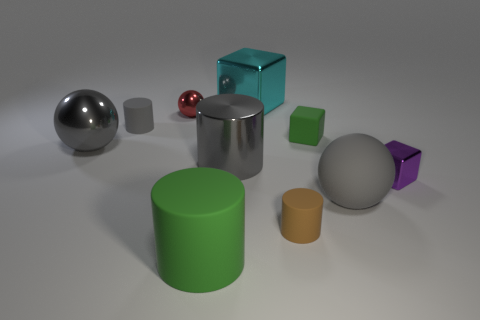Is the large matte sphere the same color as the large shiny cylinder?
Offer a very short reply. Yes. Is there a large gray metal cylinder?
Keep it short and to the point. Yes. What is the size of the metallic ball in front of the small rubber cylinder that is on the left side of the big matte cylinder in front of the large cyan metallic cube?
Ensure brevity in your answer.  Large. How many other things are the same size as the green cylinder?
Offer a terse response. 4. There is a green thing left of the large metallic cube; what size is it?
Ensure brevity in your answer.  Large. Is there any other thing that has the same color as the big rubber sphere?
Provide a succinct answer. Yes. Do the gray cylinder to the right of the small red ball and the small green cube have the same material?
Provide a succinct answer. No. How many matte objects are both in front of the large rubber ball and left of the brown object?
Your response must be concise. 1. There is a gray sphere left of the big cylinder in front of the purple metal cube; what is its size?
Give a very brief answer. Large. Are there more green shiny cylinders than spheres?
Your answer should be very brief. No. 